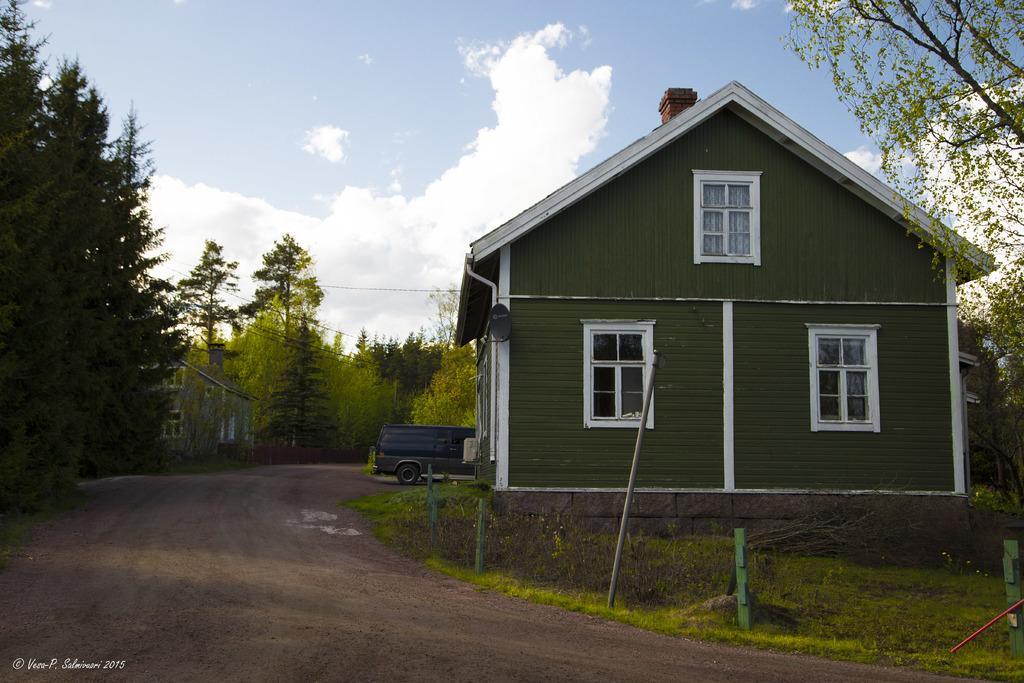In one or two sentences, can you explain what this image depicts? In this picture i can see houses and vehicle on the road. In the background i can see trees, grass and sky. On the right side i can see poles, fence and other objects on the ground. 